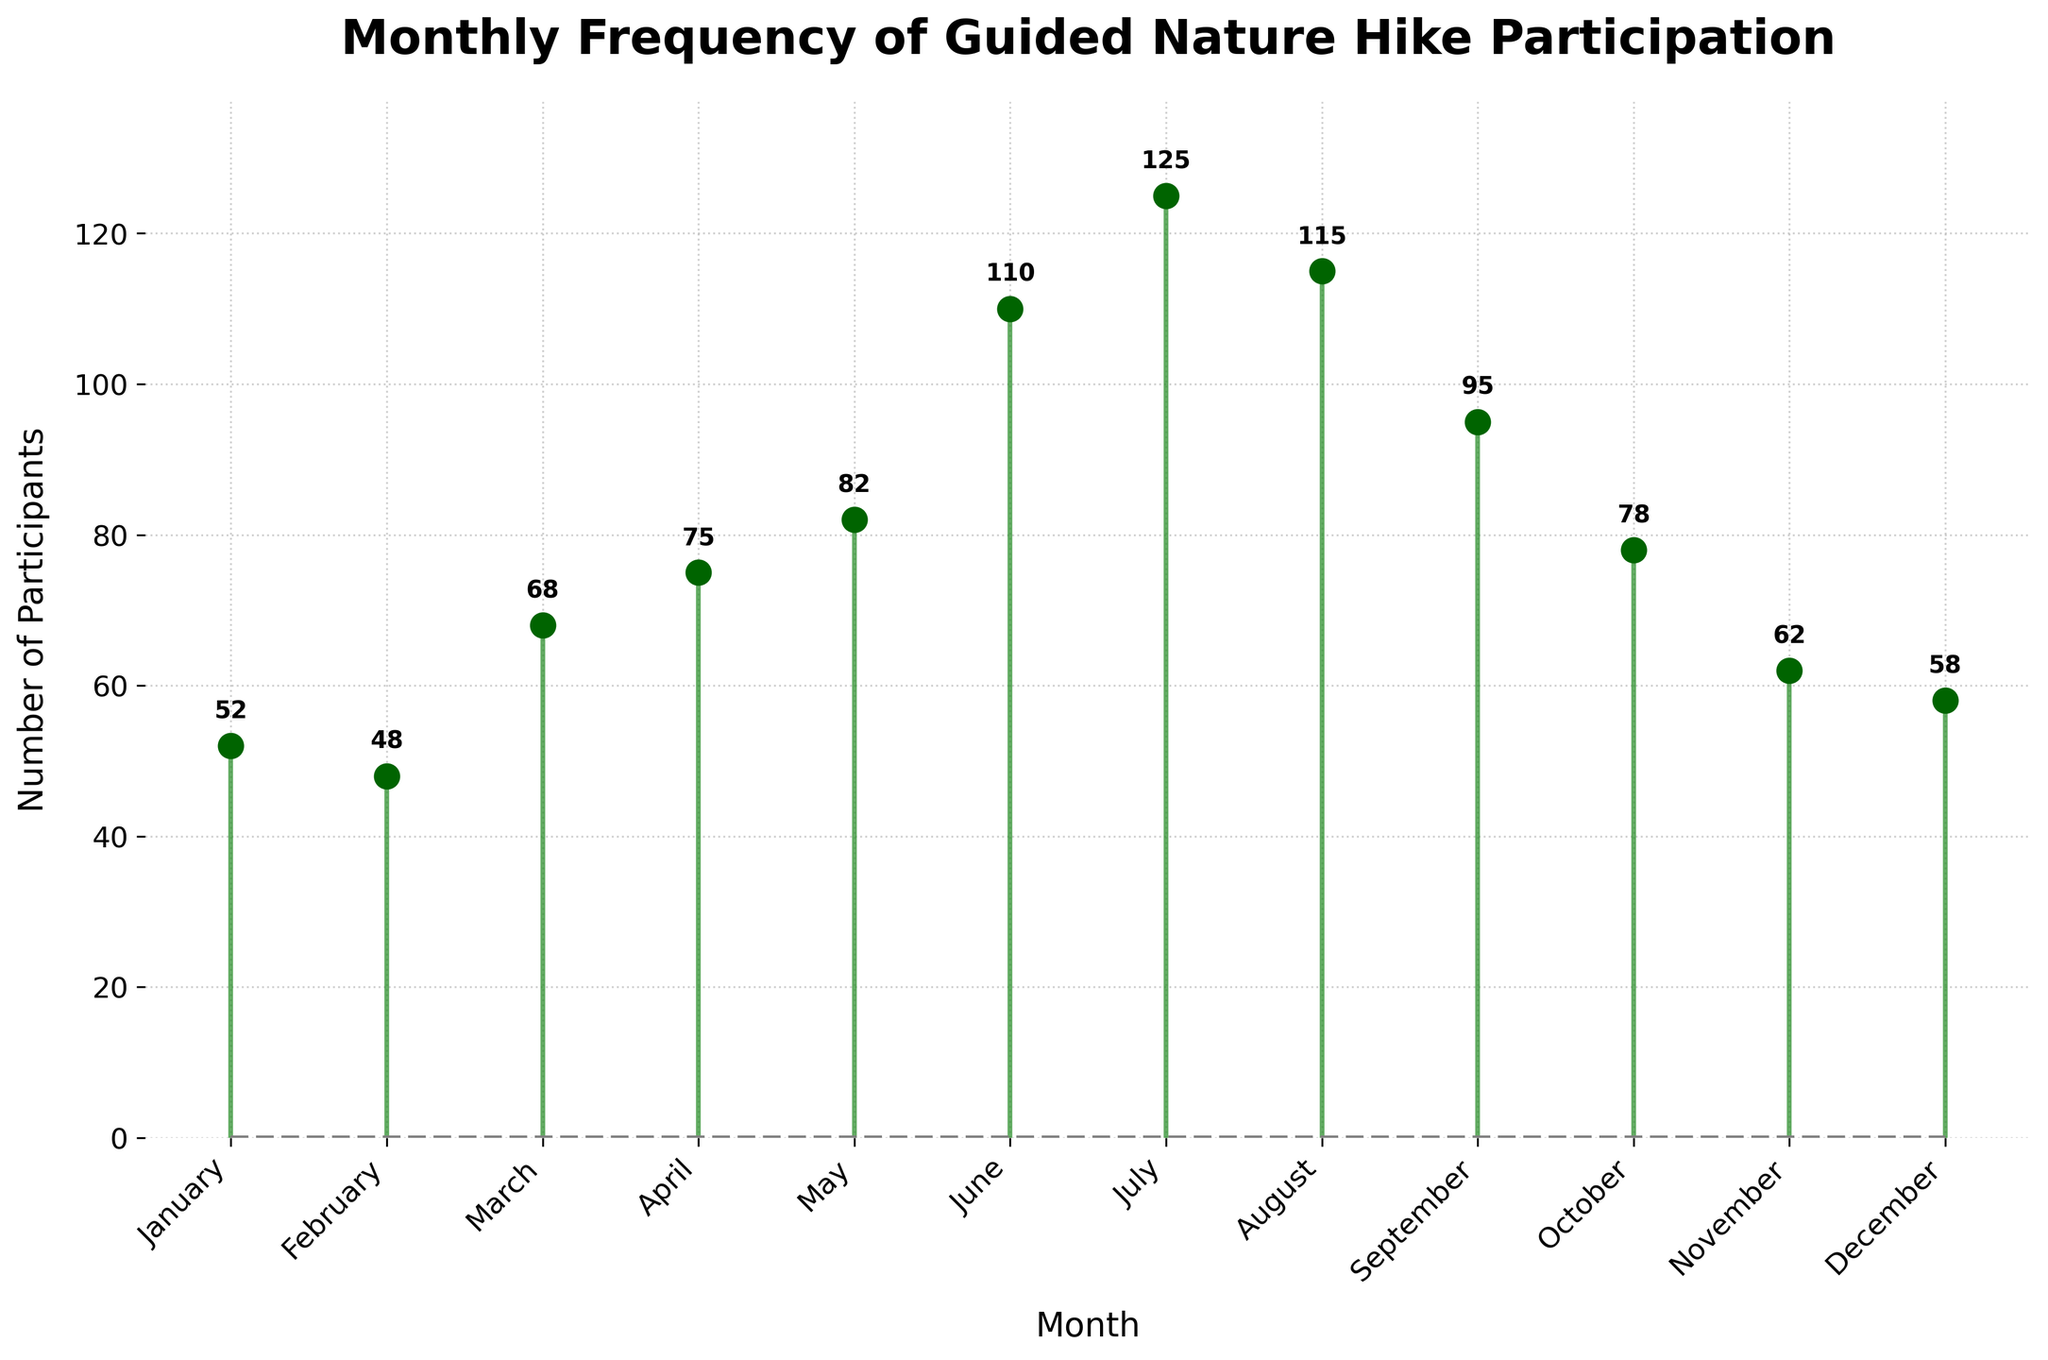What's the title of the plot? The title of the plot is usually found at the top and provides an overview of what the plot is representing. Here, the title is written clearly at the top of the figure.
Answer: Monthly Frequency of Guided Nature Hike Participation What is the highest monthly participation count and in which month did it occur? The highest participation count will correspond to the data point with the longest stem. By inspecting the plot, we see that July’s stem is the longest.
Answer: 125 in July How many months have a participation count greater than 100? To determine this, look for stems that extend above the 100 mark on the y-axis. The stems for June, July, and August all exceed 100.
Answer: 3 months What is the participation count in February? Look at the stem labeled February and see the height of the stem. The exact number is also labeled above the stem.
Answer: 48 Which month saw the lowest participation count and what was it? The lowest participation count will be the shortest stem. Here, the stem for February is the shortest.
Answer: February with 48 participants What is the difference in participation between the months with the highest and lowest counts? First, identify the two months: July has the highest (125) and February has the lowest (48). Subtract the participation count of February from that of July. 125 - 48 = 77
Answer: 77 What is the average monthly participation count? To find the average, sum all monthly participation counts and divide by the number of months. The counts are 52, 48, 68, 75, 82, 110, 125, 115, 95, 78, 62, 58. Sum = 968; divide by 12 (number of months). 968/12 = 80.67
Answer: 80.67 Which month had a significant drop in participation compared to the previous month? To identify this, check the figure for large decreases between consecutive months. Notice the drop from August (115) to September (95).
Answer: September Describe the trend in participation from June to August. Look at the stems for June, July, and August in sequence. The participation count increases from June (110) to July (125), then drops to August (115).
Answer: A rise in July and a drop in August How is the baseline depicted in the plot and what is its purpose? The baseline is depicted as a gray dashed line across the bottom of the plot. It marks the starting point of the stems and helps in visual comparison of varying stem lengths.
Answer: Gray dashed line, helps in comparison 